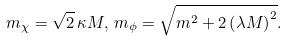<formula> <loc_0><loc_0><loc_500><loc_500>m _ { \chi } = \sqrt { 2 } \, \kappa M , \, m _ { \phi } = \sqrt { m ^ { 2 } + 2 \left ( \lambda M \right ) ^ { 2 } } .</formula> 